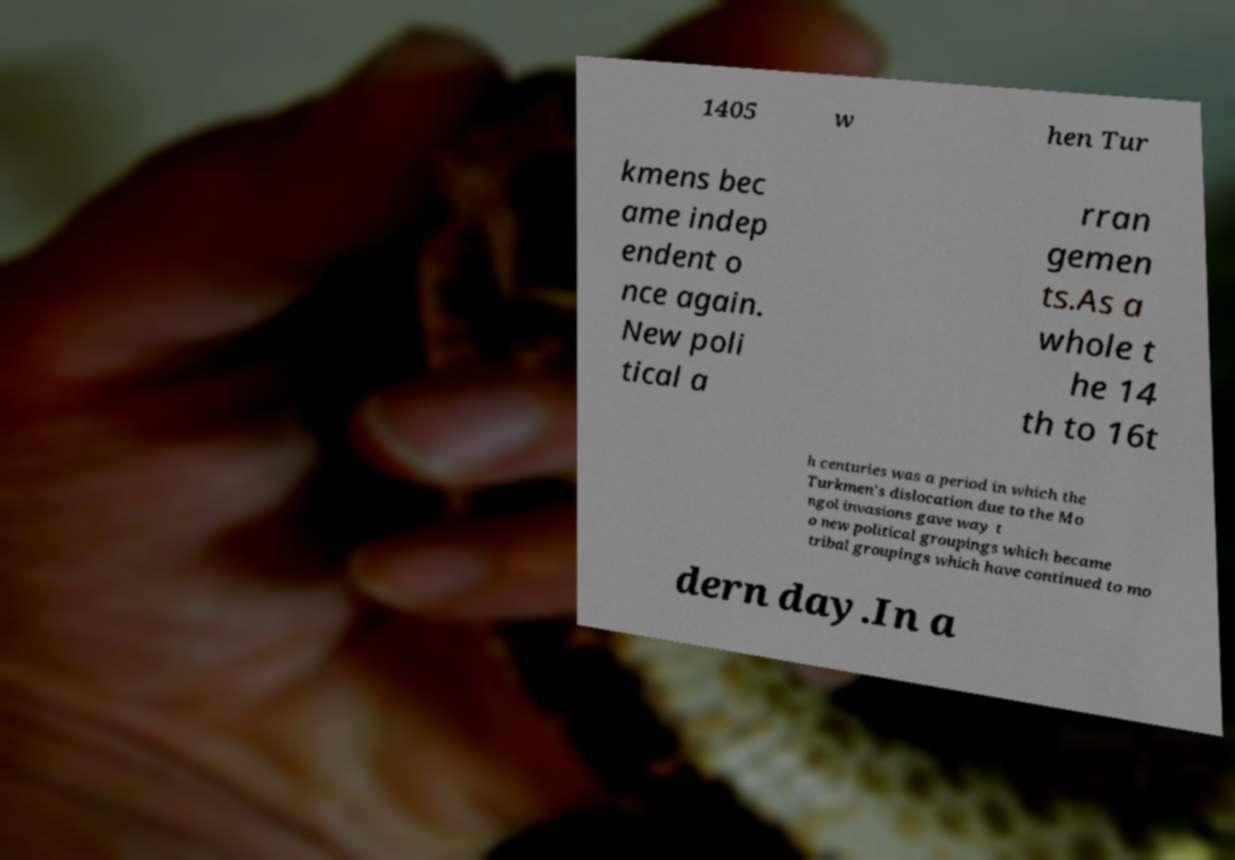There's text embedded in this image that I need extracted. Can you transcribe it verbatim? 1405 w hen Tur kmens bec ame indep endent o nce again. New poli tical a rran gemen ts.As a whole t he 14 th to 16t h centuries was a period in which the Turkmen's dislocation due to the Mo ngol invasions gave way t o new political groupings which became tribal groupings which have continued to mo dern day.In a 